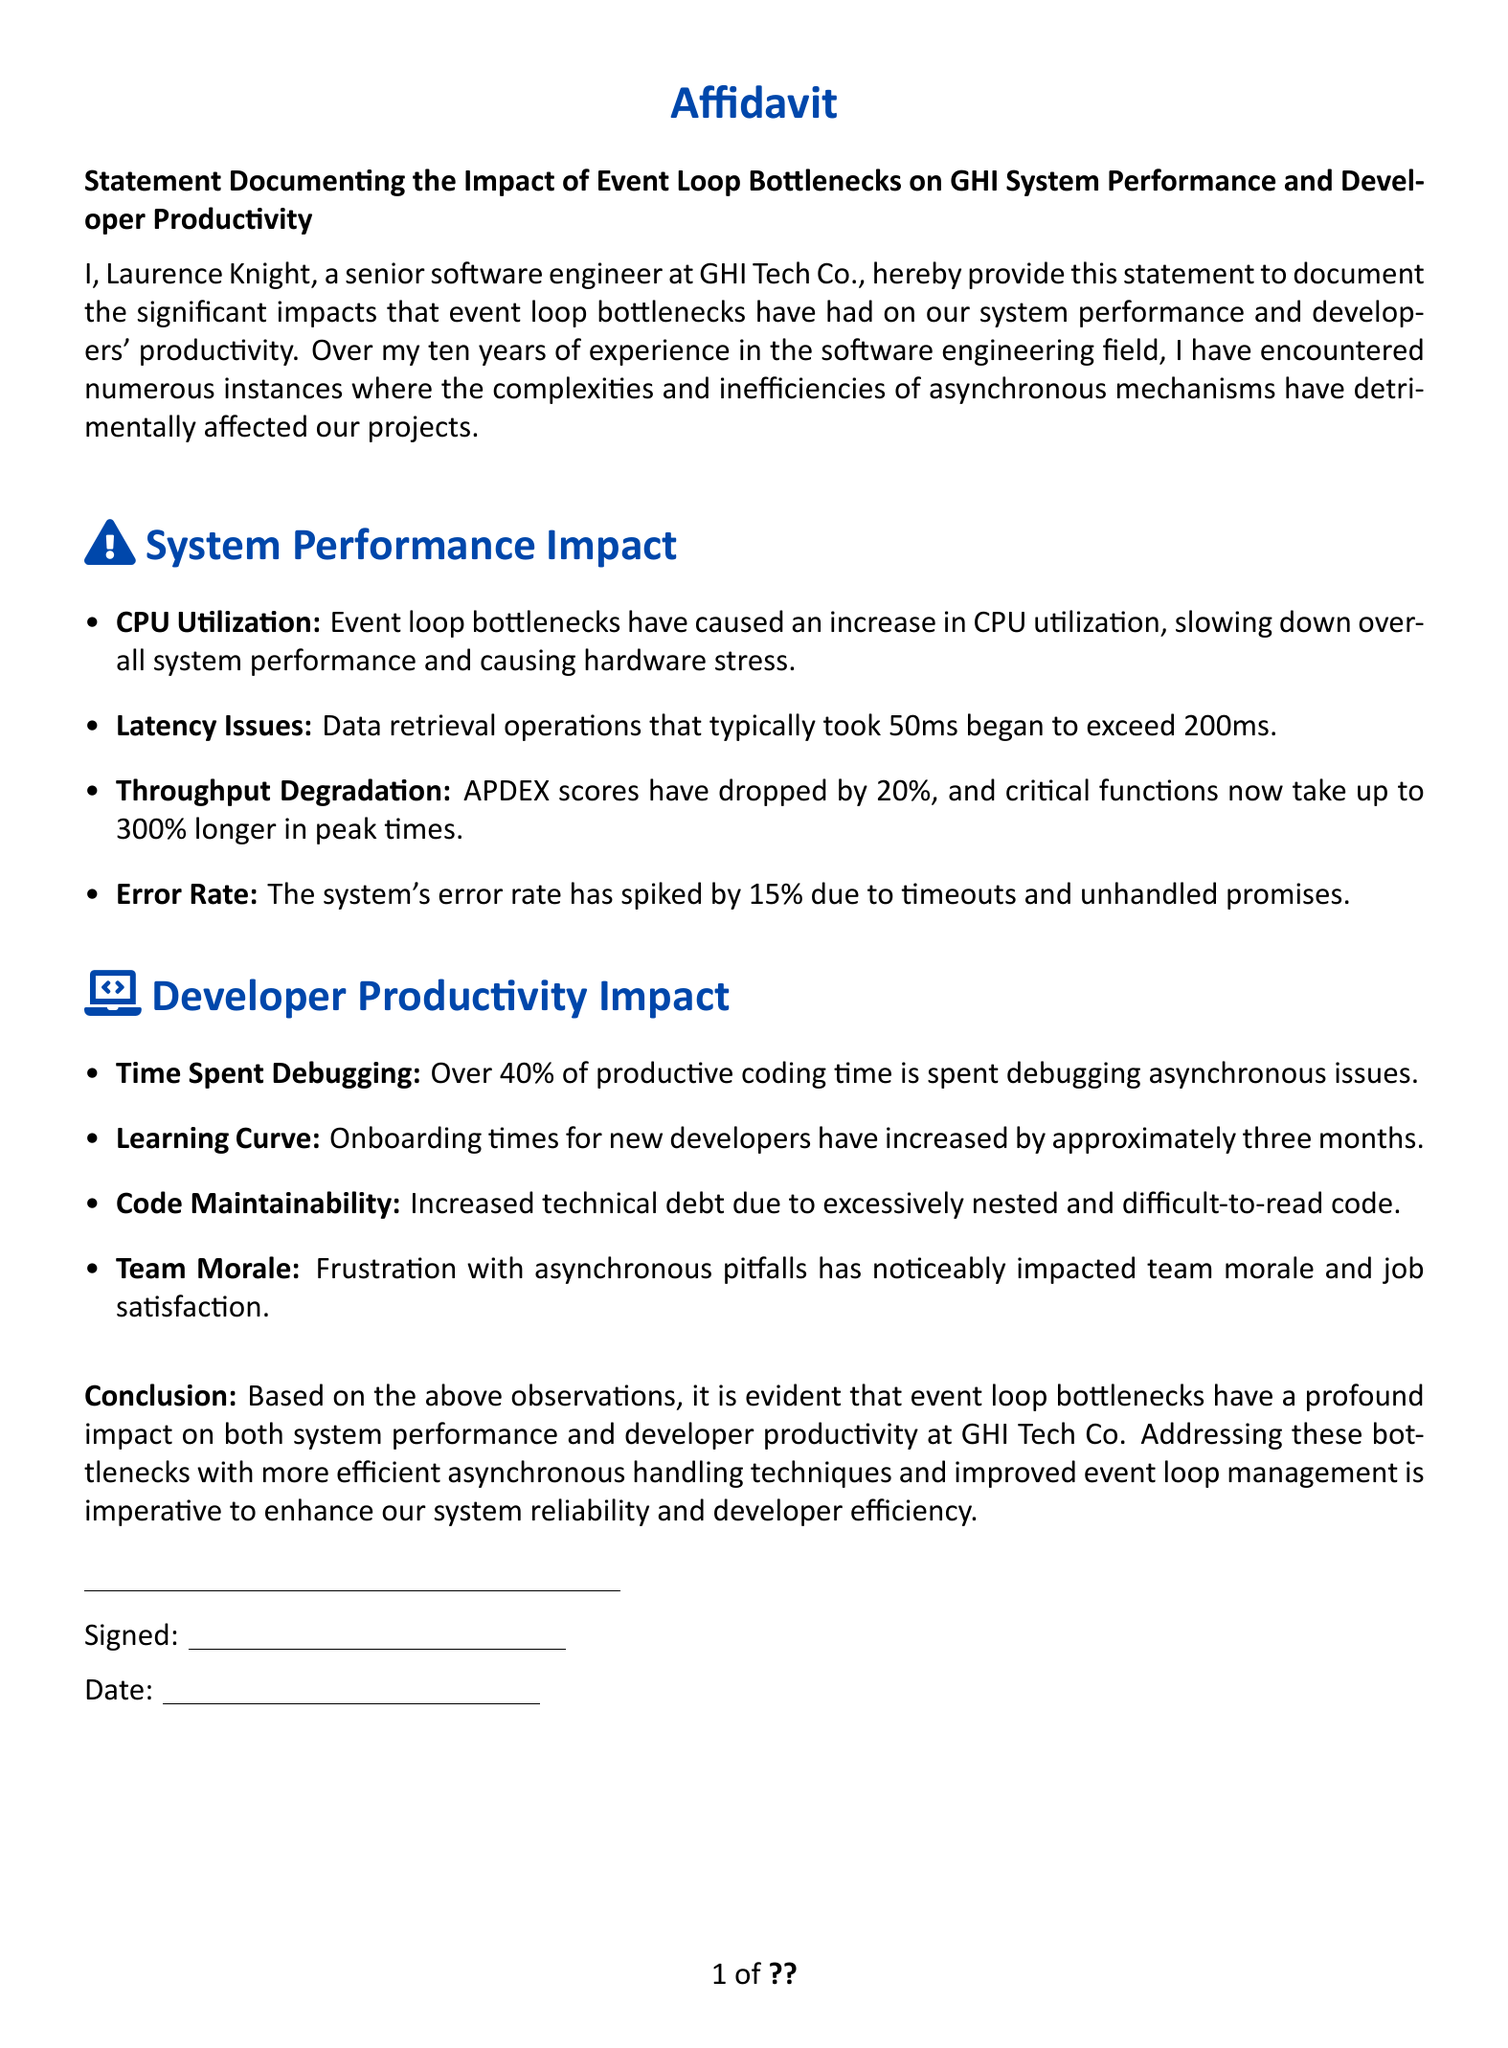what is the title of the document? The title is found at the beginning of the document, which reads "Statement Documenting the Impact of Event Loop Bottlenecks on GHI System Performance and Developer Productivity."
Answer: Statement Documenting the Impact of Event Loop Bottlenecks on GHI System Performance and Developer Productivity who authored the affidavit? The author is identified in the document as Laurence Knight.
Answer: Laurence Knight how much has the APDEX score dropped? The document states that APDEX scores have dropped by 20%.
Answer: 20% what percentage of coding time is spent debugging asynchronous issues? The document mentions that over 40% of productive coding time is spent debugging asynchronous issues.
Answer: 40% what is the impact on onboarding times for new developers? The document states that onboarding times for new developers have increased by approximately three months.
Answer: three months what is a significant effect on team morale mentioned in the document? The document highlights that frustration with asynchronous pitfalls has noticeably impacted team morale and job satisfaction.
Answer: job satisfaction how has the error rate changed according to the affidavit? The affidavit indicates that the system's error rate has spiked by 15%.
Answer: 15% what conclusion does the document draw? The conclusion in the affidavit emphasizes the need for addressing event loop bottlenecks.
Answer: addressing these bottlenecks is imperative to enhance our system reliability and developer efficiency 